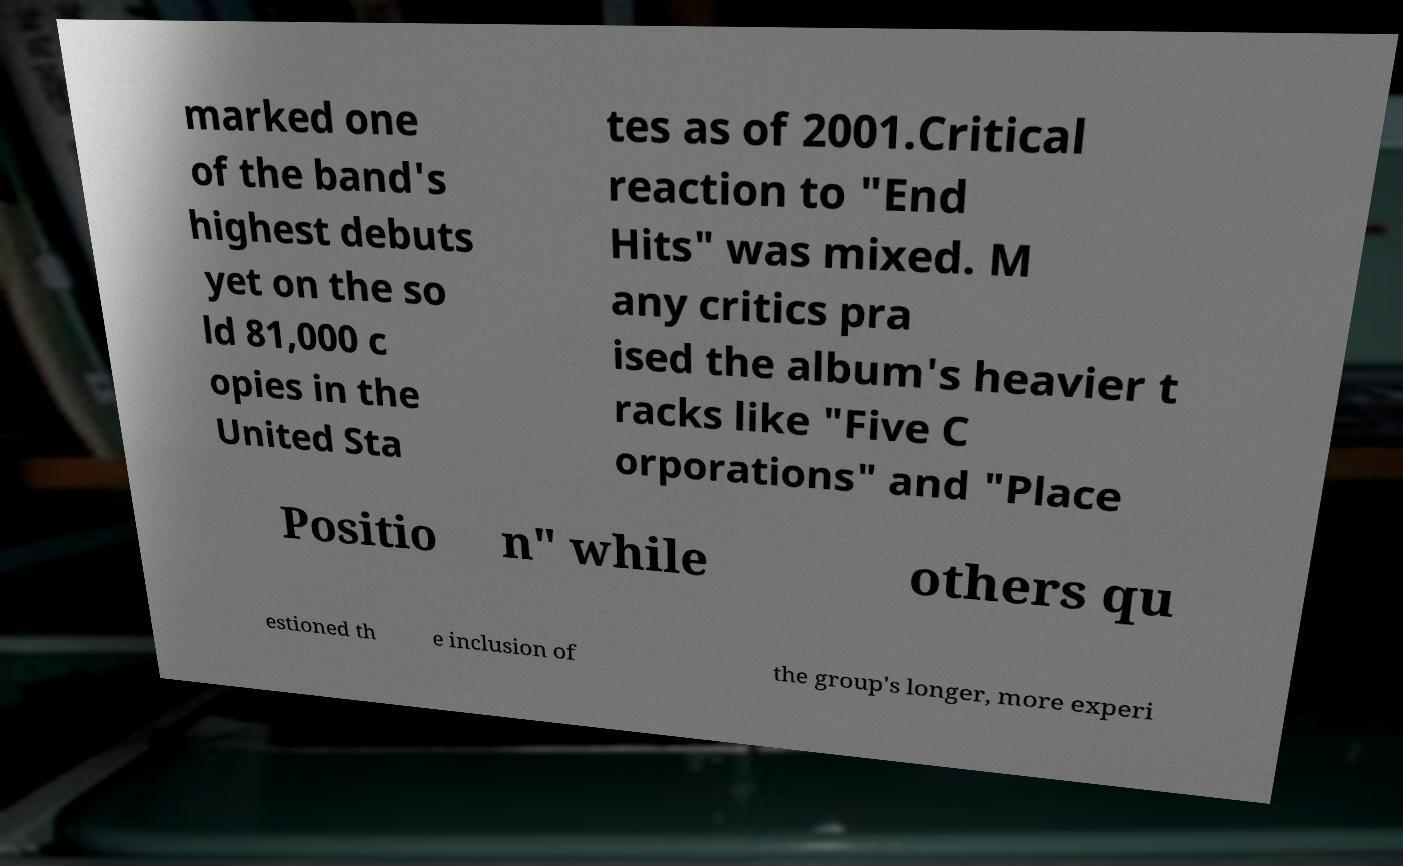Could you extract and type out the text from this image? marked one of the band's highest debuts yet on the so ld 81,000 c opies in the United Sta tes as of 2001.Critical reaction to "End Hits" was mixed. M any critics pra ised the album's heavier t racks like "Five C orporations" and "Place Positio n" while others qu estioned th e inclusion of the group's longer, more experi 